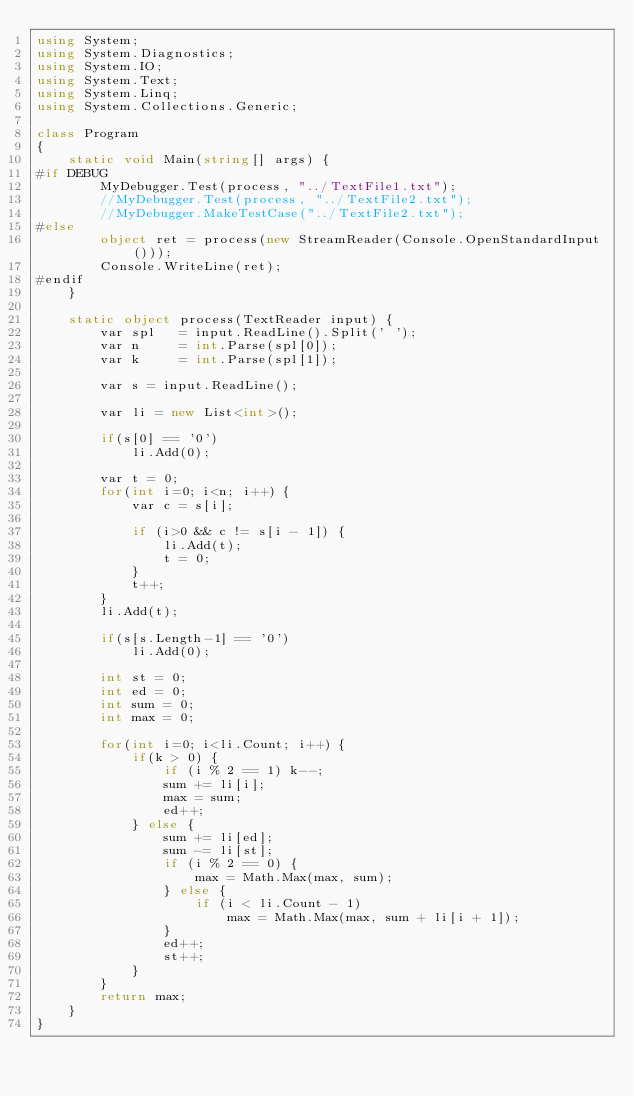Convert code to text. <code><loc_0><loc_0><loc_500><loc_500><_C#_>using System;
using System.Diagnostics;
using System.IO;
using System.Text;
using System.Linq;
using System.Collections.Generic;

class Program
{
    static void Main(string[] args) {
#if DEBUG
        MyDebugger.Test(process, "../TextFile1.txt");
        //MyDebugger.Test(process, "../TextFile2.txt");
        //MyDebugger.MakeTestCase("../TextFile2.txt");
#else
        object ret = process(new StreamReader(Console.OpenStandardInput()));
        Console.WriteLine(ret);
#endif
    }

    static object process(TextReader input) {
        var spl   = input.ReadLine().Split(' ');
        var n     = int.Parse(spl[0]);
        var k     = int.Parse(spl[1]);

        var s = input.ReadLine();

        var li = new List<int>();
        
        if(s[0] == '0')
            li.Add(0);

        var t = 0;
        for(int i=0; i<n; i++) {
            var c = s[i];

            if (i>0 && c != s[i - 1]) {
                li.Add(t);
                t = 0;
            }
            t++;
        }
        li.Add(t);

        if(s[s.Length-1] == '0')
            li.Add(0);

        int st = 0;
        int ed = 0;
        int sum = 0;
        int max = 0;

        for(int i=0; i<li.Count; i++) {
            if(k > 0) {
                if (i % 2 == 1) k--;
                sum += li[i];
                max = sum;
                ed++;
            } else {
                sum += li[ed];
                sum -= li[st];
                if (i % 2 == 0) {
                    max = Math.Max(max, sum);
                } else {
                    if (i < li.Count - 1)
                        max = Math.Max(max, sum + li[i + 1]);
                }
                ed++;
                st++;
            }
        }
        return max;
    }
}</code> 